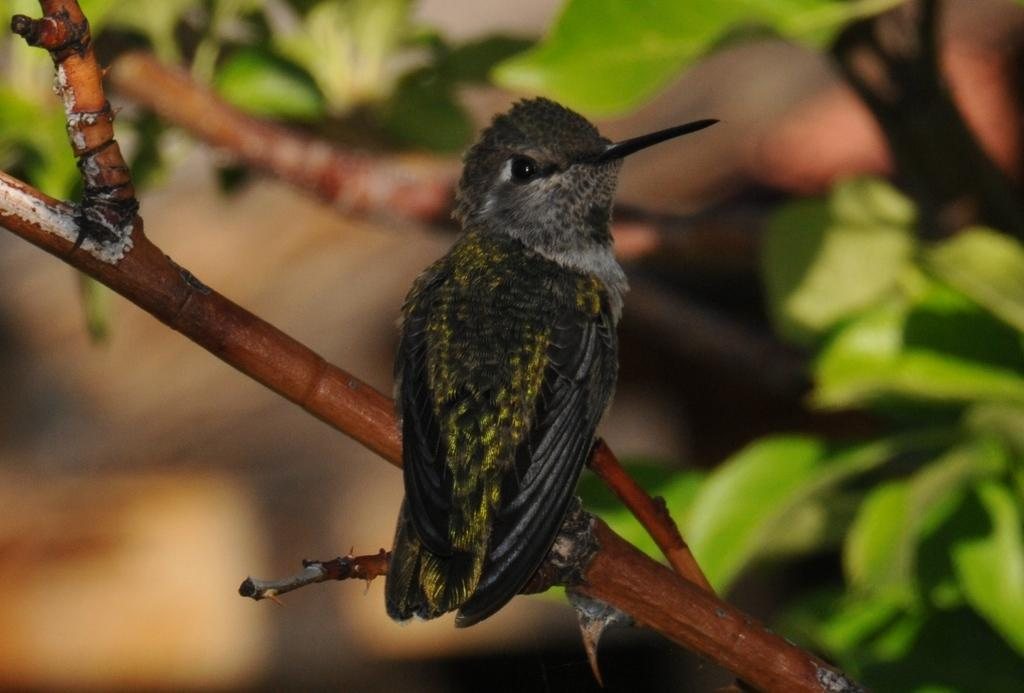What type of animal can be seen in the image? There is a bird in the image. What is the bird perched on in the image? There is a tree in the image. How many cakes are being taxed in the image? There are no cakes or references to taxation present in the image. 